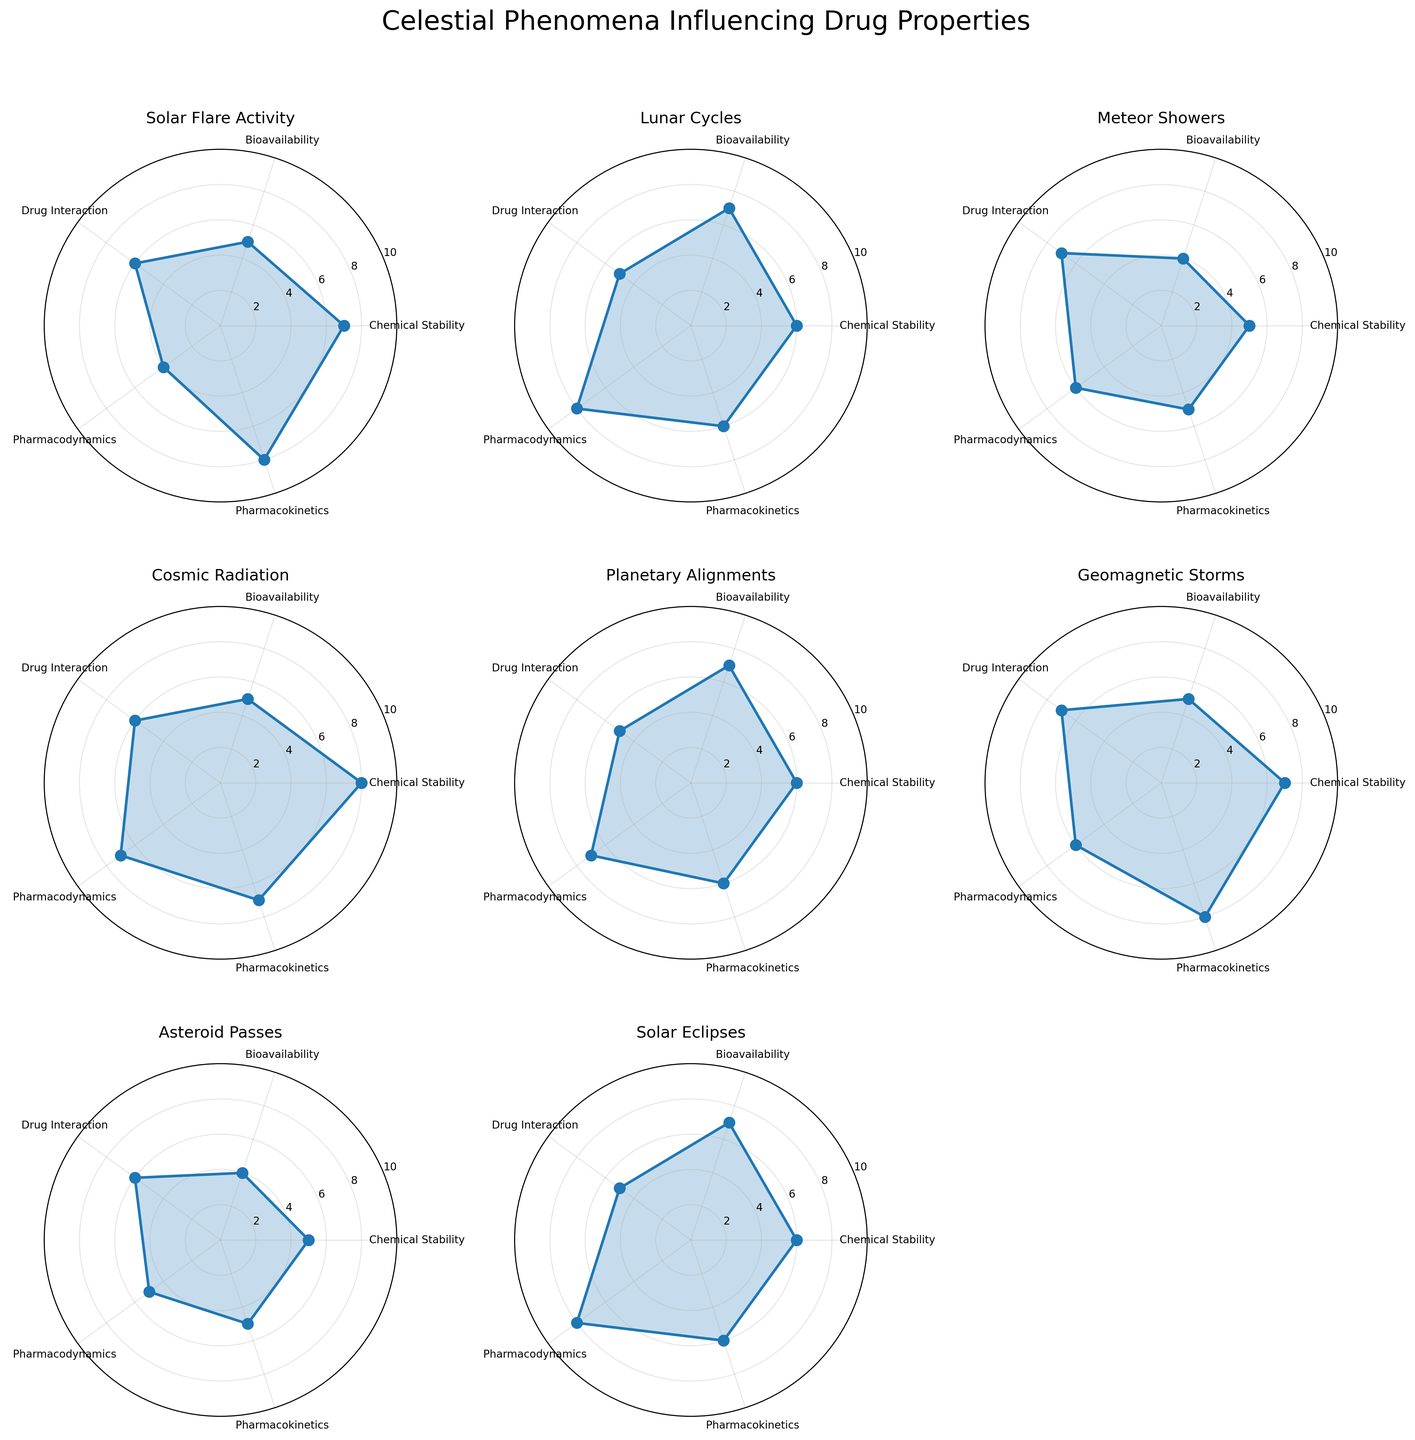How many celestial phenomena are plotted in the figure? There are eight subplots in the figure, each representing a different celestial phenomenon.
Answer: Eight Which celestial phenomenon has the highest value for Chemical Stability? Look at the subplot for each celestial phenomenon and compare their Chemical Stability values. Cosmic Radiation has the highest value at 8.
Answer: Cosmic Radiation Compare the Bioavailability between Solar Flare Activity and Geomagnetic Storms. Which has a higher value? The Bioavailability for Solar Flare Activity is 5, while for Geomagnetic Storms it is also 5.
Answer: They are equal What is the average value of Drug Interaction across all celestial phenomena? Add up the Drug Interaction values for all celestial phenomena (6+5+7+6+5+7+6+5) which equals 47 and divide by 8 phenomena.
Answer: 5.875 Which celestial phenomenon shows the highest Pharmacokinetics value and what is it? Examine each subplot and compare the Pharmacokinetics values. Both Solar Flare Activity and Geomagnetic Storms have the highest value at 8.
Answer: Solar Flare Activity and Geomagnetic Storms, 8 Is there any celestial phenomenon where all five drug properties have values of 6 or higher? For each subplot, check if all categories (Chemical Stability, Bioavailability, Drug Interaction, Pharmacodynamics, and Pharmacokinetics) are 6 or more. None meet this criteria.
Answer: No Compare the Pharmacodynamics values between Lunar Cycles and Solar Eclipses. Which one is higher? Check the Pharmacodynamics values for Lunar Cycles (8) and Solar Eclipses (8).
Answer: They are equal Which celestial phenomenon has the most balanced (least varying) influence across all five drug properties? Look for the subplot where the values across all properties are most similar. Comet Appearances, with values of 5, 6, 5, 6, and 5, appears most balanced.
Answer: Comet Appearances Calculate the total score (sum of all five drug properties) for Planetary Alignments. Sum the values for Planetary Alignments: 6 (Chemical Stability) + 7 (Bioavailability) + 5 (Drug Interaction) + 7 (Pharmacodynamics) + 6 (Pharmacokinetics).
Answer: 31 Are there any celestial phenomena with identical profiles (all five properties have the same values)? Check if any subplots have identical values across Chemical Stability, Bioavailability, Drug Interaction, Pharmacodynamics, and Pharmacokinetics. There are no identical profiles.
Answer: No 